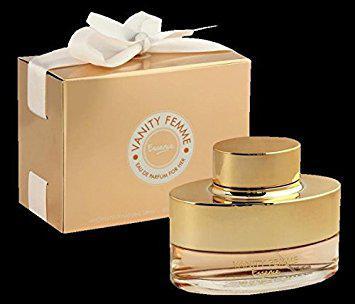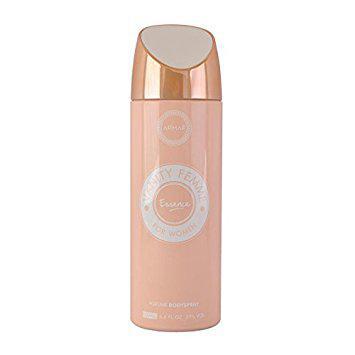The first image is the image on the left, the second image is the image on the right. For the images shown, is this caption "one of the images contains a cylinder." true? Answer yes or no. Yes. 